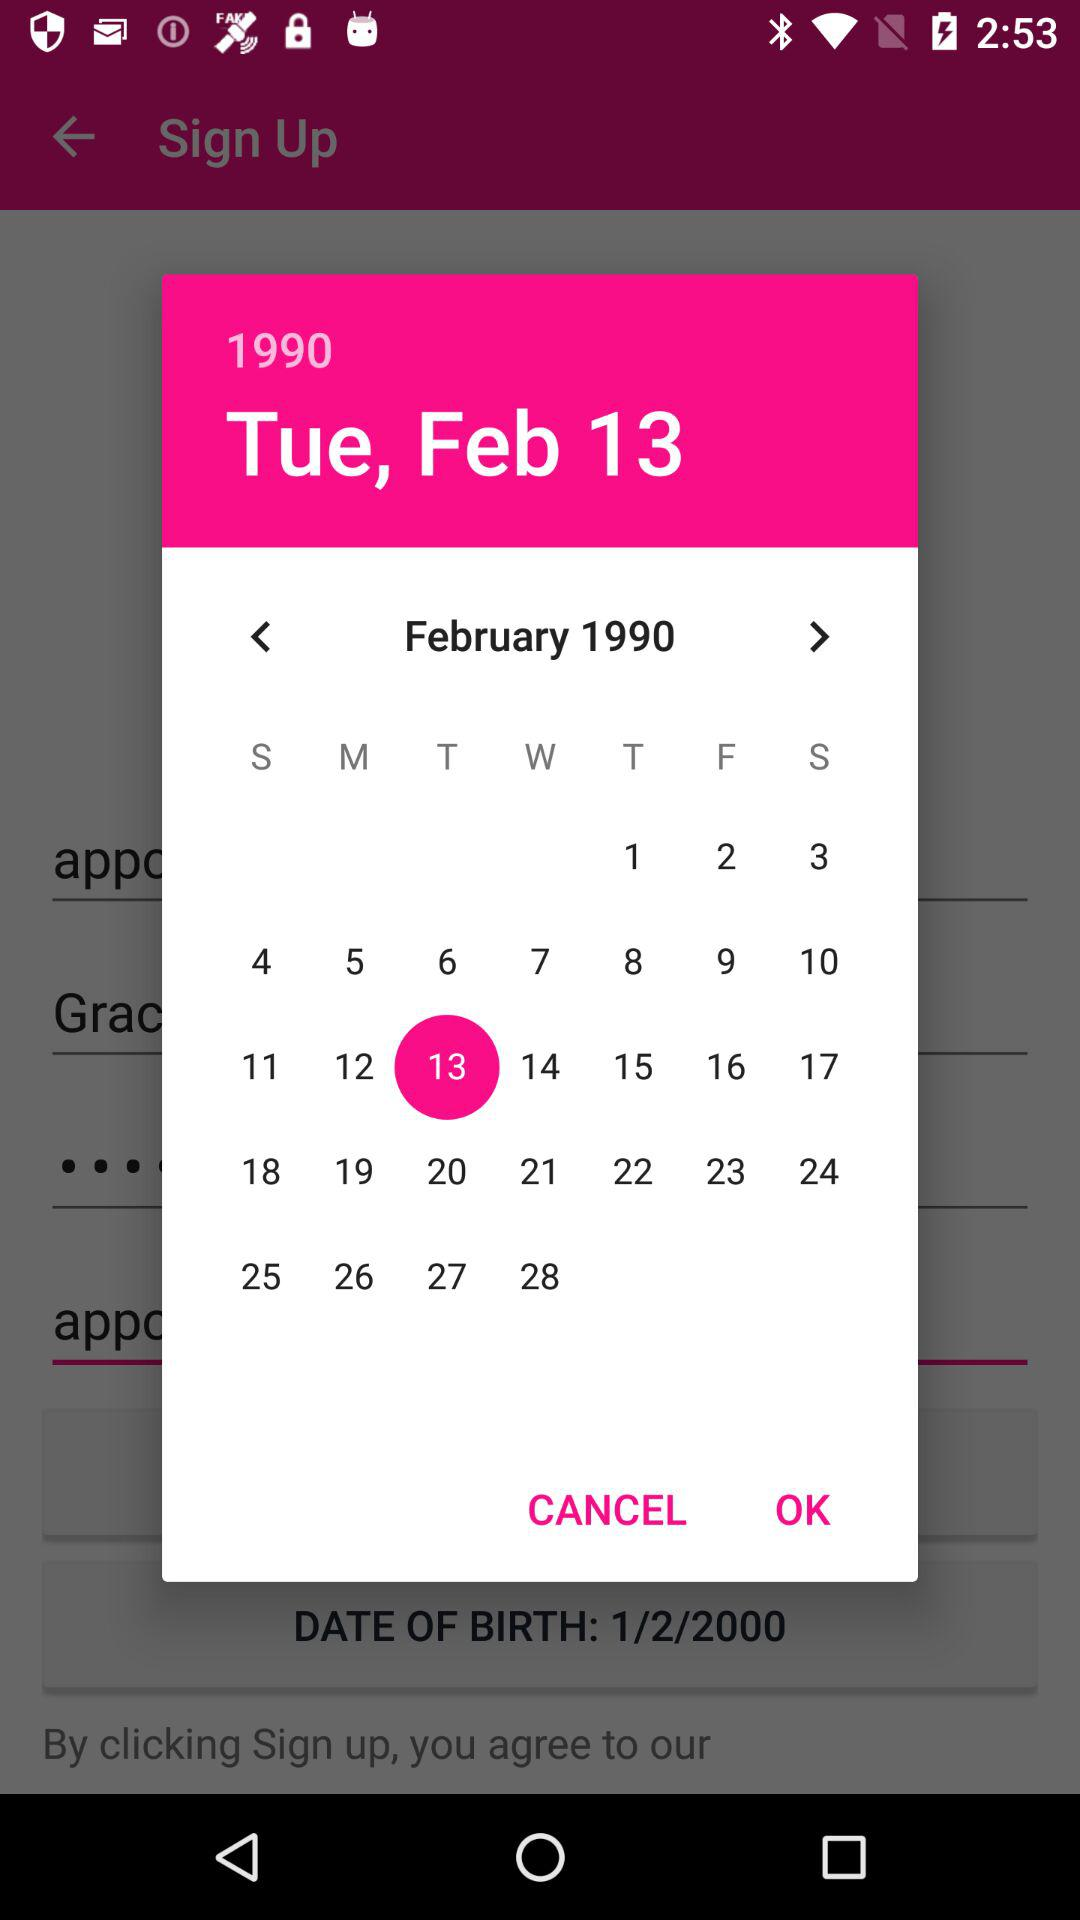What is the selected year? The selected year is 1990. 